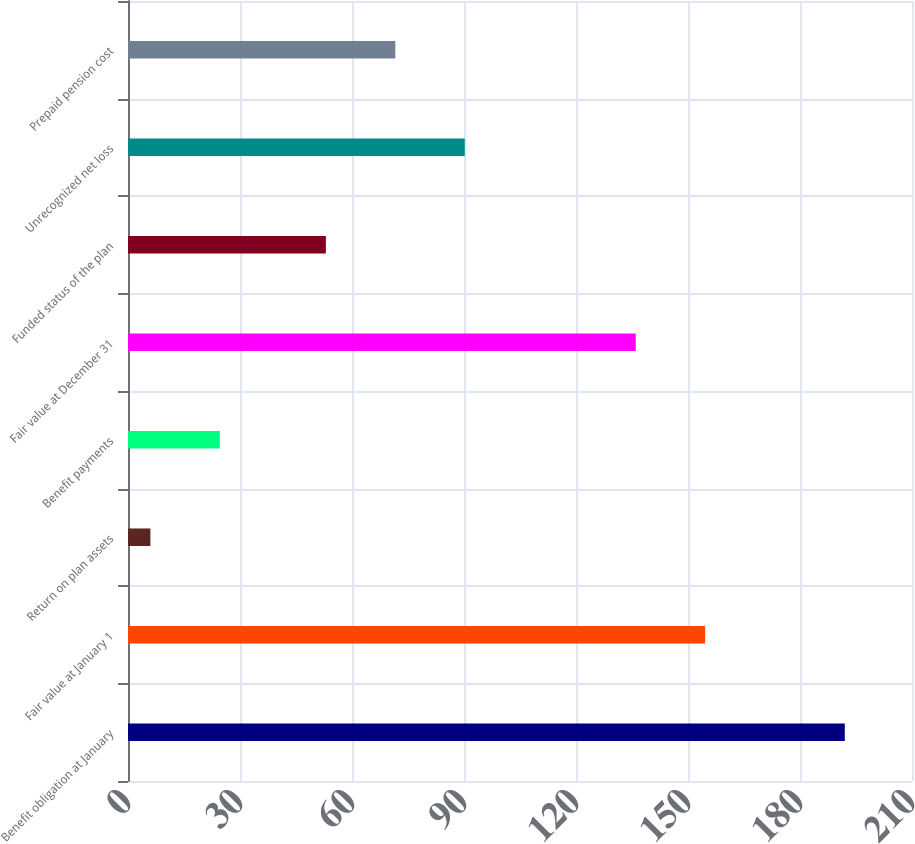<chart> <loc_0><loc_0><loc_500><loc_500><bar_chart><fcel>Benefit obligation at January<fcel>Fair value at January 1<fcel>Return on plan assets<fcel>Benefit payments<fcel>Fair value at December 31<fcel>Funded status of the plan<fcel>Unrecognized net loss<fcel>Prepaid pension cost<nl><fcel>192<fcel>154.6<fcel>6<fcel>24.6<fcel>136<fcel>53<fcel>90.2<fcel>71.6<nl></chart> 